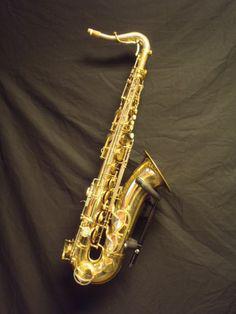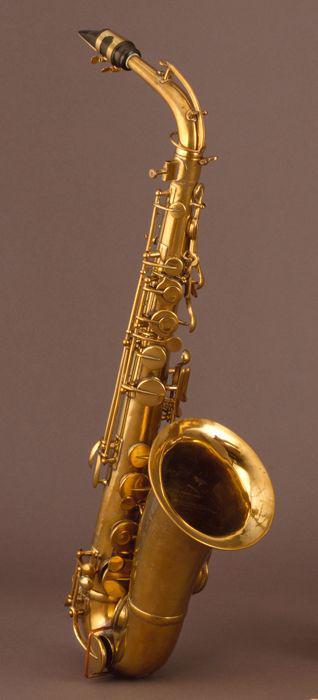The first image is the image on the left, the second image is the image on the right. Evaluate the accuracy of this statement regarding the images: "At least one instrument is laying on a gray cloth.". Is it true? Answer yes or no. Yes. The first image is the image on the left, the second image is the image on the right. Given the left and right images, does the statement "An image shows one saxophone that seems to be standing up on a flat ground, instead of lying flat or floating." hold true? Answer yes or no. Yes. 